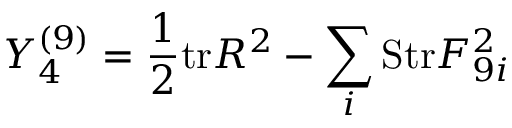<formula> <loc_0><loc_0><loc_500><loc_500>Y _ { 4 } ^ { ( 9 ) } = { \frac { 1 } { 2 } } t r R ^ { 2 } - \sum _ { i } S t r F _ { 9 i } ^ { 2 }</formula> 